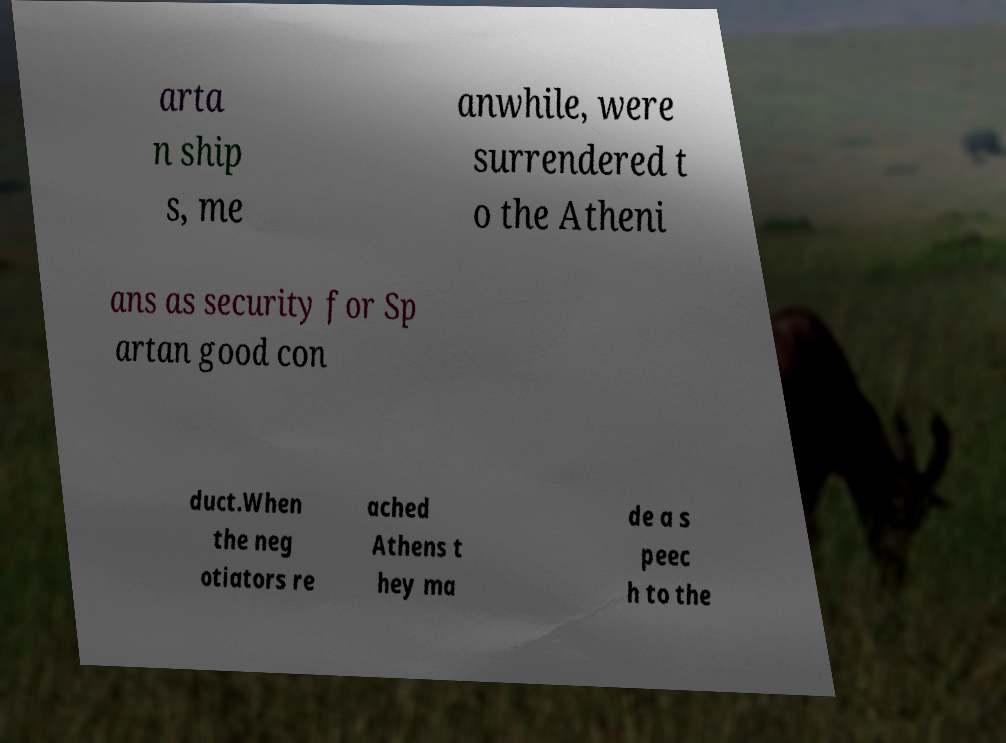Please read and relay the text visible in this image. What does it say? arta n ship s, me anwhile, were surrendered t o the Atheni ans as security for Sp artan good con duct.When the neg otiators re ached Athens t hey ma de a s peec h to the 